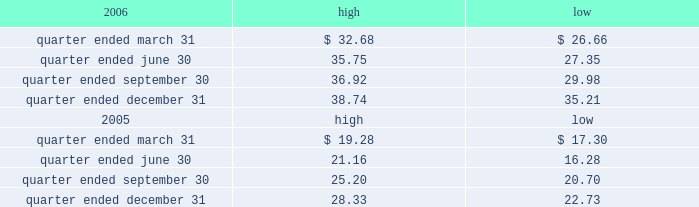Part ii item 5 .
Market for registrant 2019s common equity , related stockholder matters and issuer purchases of equity securities the table presents reported quarterly high and low per share sale prices of our class a common stock on the new york stock exchange ( nyse ) for the years 2006 and 2005. .
On february 22 , 2007 , the closing price of our class a common stock was $ 40.38 per share as reported on the nyse .
As of february 22 , 2007 , we had 419988395 outstanding shares of class a common stock and 623 registered holders .
In february 2004 , all outstanding shares of our class b common stock were converted into shares of our class a common stock on a one-for-one basis pursuant to the occurrence of the 201cdodge conversion event 201d as defined in our charter .
Also in february 2004 , all outstanding shares of class c common stock were converted into shares of class a common stock on a one-for-one basis .
In august 2005 , we amended and restated our charter to , among other things , eliminate our class b common stock and class c common stock .
Dividends we have never paid a dividend on any class of our common stock .
We anticipate that we may retain future earnings , if any , to fund the development and growth of our business .
The indentures governing our 7.50% ( 7.50 % ) senior notes due 2012 ( 7.50% ( 7.50 % ) notes ) and our 7.125% ( 7.125 % ) senior notes due 2012 ( 7.125% ( 7.125 % ) notes ) may prohibit us from paying dividends to our stockholders unless we satisfy certain financial covenants .
Our credit facilities and the indentures governing the terms of our debt securities contain covenants that may restrict the ability of our subsidiaries from making to us any direct or indirect distribution , dividend or other payment on account of their limited liability company interests , partnership interests , capital stock or other equity interests .
Under our credit facilities , the borrower subsidiaries may pay cash dividends or make other distributions to us in accordance with the applicable credit facility only if no default exists or would be created thereby .
The indenture governing the terms of the ati 7.25% ( 7.25 % ) notes prohibit ati and certain of our other subsidiaries that have guaranteed those notes ( sister guarantors ) from paying dividends and making other payments or distributions to us unless certain financial covenants are satisfied .
The indentures governing the terms of our 7.50% ( 7.50 % ) notes and 7.125% ( 7.125 % ) notes also contain certain restrictive covenants , which prohibit the restricted subsidiaries under these indentures from paying dividends and making other payments or distributions to us unless certain financial covenants are satisfied .
For more information about the restrictions under our credit facilities and our notes indentures , see item 7 of this annual report under the caption 201cmanagement 2019s discussion and analysis of financial condition and results of operations 2014liquidity and capital resources 2014factors affecting sources of liquidity 201d and note 7 to our consolidated financial statements included in this annual report. .
What was the market capitalization on february 222007? 
Computations: (419988395 * 40.38)
Answer: 16959131390.1. 